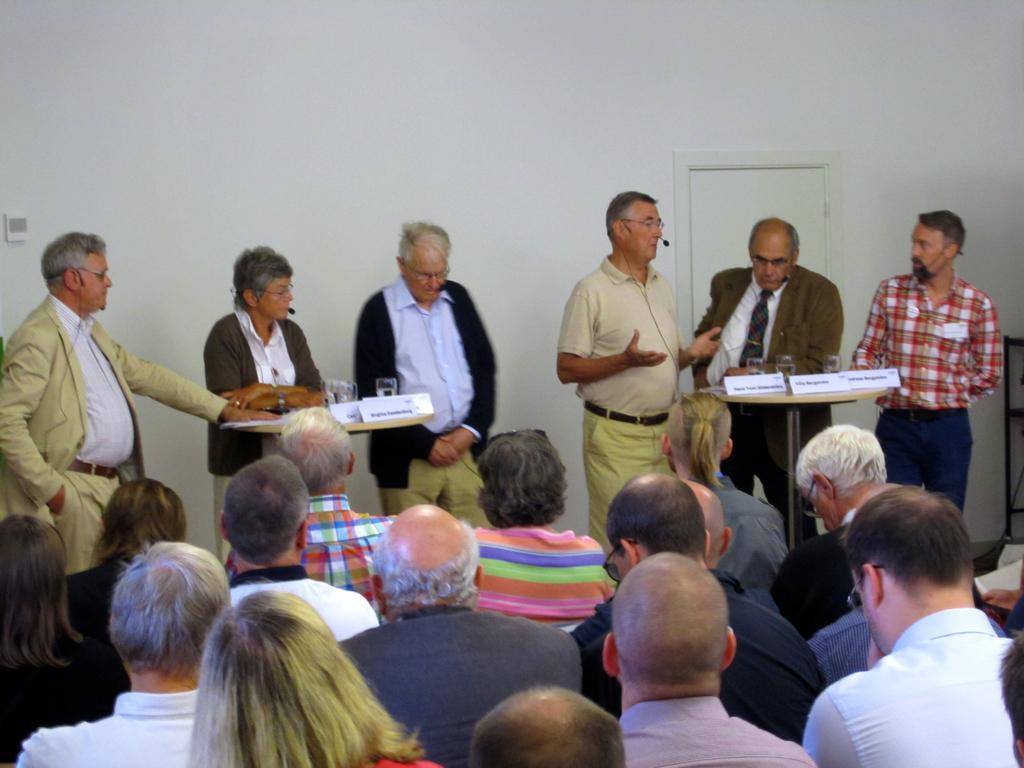Describe this image in one or two sentences. In this image I can see there are six persons standing and at the bottom I can see few persons and on the right side I can see a table , on the table I can see a papers ,at the top I can see white color wall. 